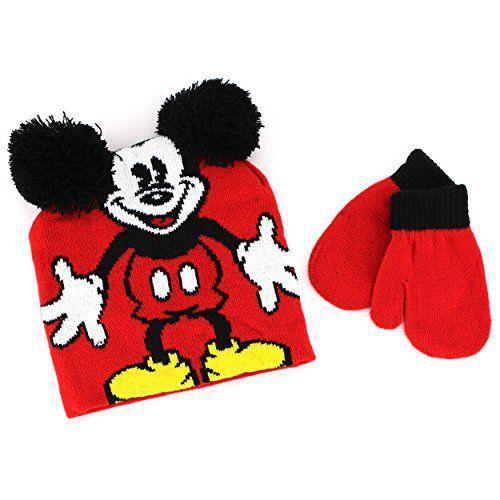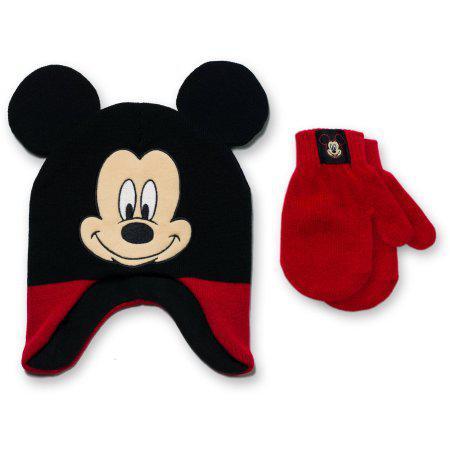The first image is the image on the left, the second image is the image on the right. Assess this claim about the two images: "There is one black and red hat with black mouse ears and two white dots on it beside two red mittens with white Mickey Mouse logos and black cuffs in each image,.". Correct or not? Answer yes or no. No. The first image is the image on the left, the second image is the image on the right. Analyze the images presented: Is the assertion "One hat is black and red with two white button dots and one pair of red and black gloves has a white Mickey Mouse shape on each glove." valid? Answer yes or no. No. 